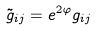<formula> <loc_0><loc_0><loc_500><loc_500>\tilde { g } _ { i j } = e ^ { 2 \varphi } g _ { i j }</formula> 